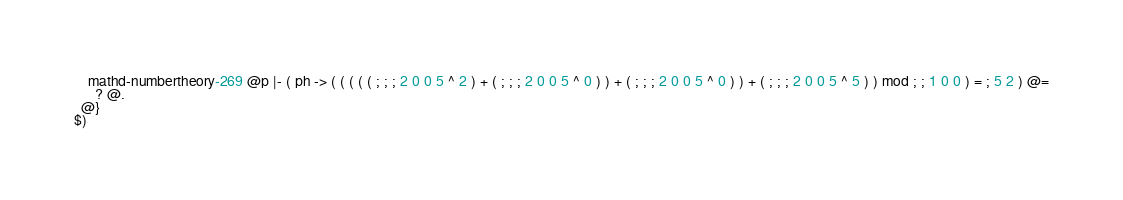Convert code to text. <code><loc_0><loc_0><loc_500><loc_500><_ObjectiveC_>    mathd-numbertheory-269 @p |- ( ph -> ( ( ( ( ( ; ; ; 2 0 0 5 ^ 2 ) + ( ; ; ; 2 0 0 5 ^ 0 ) ) + ( ; ; ; 2 0 0 5 ^ 0 ) ) + ( ; ; ; 2 0 0 5 ^ 5 ) ) mod ; ; 1 0 0 ) = ; 5 2 ) @=
      ? @.
  @}
$)
</code> 